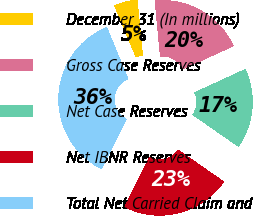Convert chart to OTSL. <chart><loc_0><loc_0><loc_500><loc_500><pie_chart><fcel>December 31 (In millions)<fcel>Gross Case Reserves<fcel>Net Case Reserves<fcel>Net IBNR Reserves<fcel>Total Net Carried Claim and<nl><fcel>4.76%<fcel>19.66%<fcel>16.51%<fcel>22.81%<fcel>36.27%<nl></chart> 